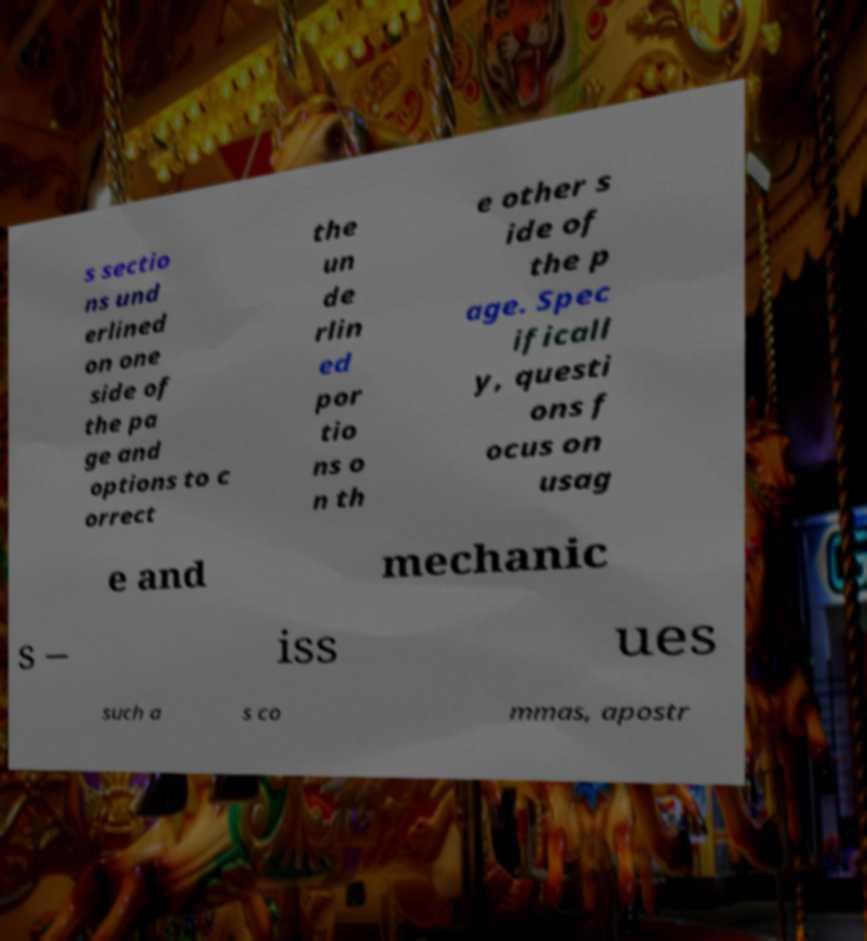Can you accurately transcribe the text from the provided image for me? s sectio ns und erlined on one side of the pa ge and options to c orrect the un de rlin ed por tio ns o n th e other s ide of the p age. Spec ificall y, questi ons f ocus on usag e and mechanic s – iss ues such a s co mmas, apostr 